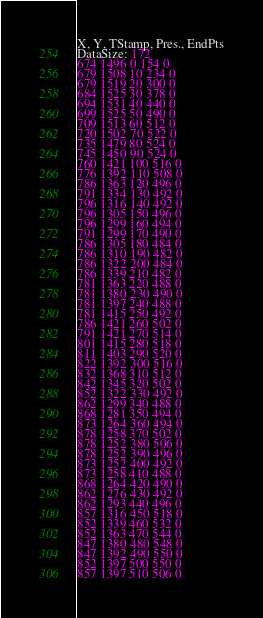<code> <loc_0><loc_0><loc_500><loc_500><_SML_>X, Y, TStamp, Pres., EndPts
DataSize: 172
674 1496 0 154 0
679 1508 10 234 0
679 1519 20 300 0
684 1525 30 378 0
694 1531 40 440 0
699 1525 50 490 0
709 1513 60 512 0
720 1502 70 522 0
735 1479 80 524 0
745 1450 90 524 0
760 1421 100 516 0
776 1392 110 508 0
786 1363 120 496 0
791 1334 130 492 0
796 1316 140 492 0
796 1305 150 496 0
796 1299 160 494 0
791 1299 170 490 0
786 1305 180 484 0
786 1310 190 482 0
786 1322 200 484 0
786 1339 210 482 0
781 1363 220 488 0
781 1380 230 490 0
781 1397 240 488 0
781 1415 250 492 0
786 1421 260 502 0
791 1421 270 514 0
801 1415 280 518 0
811 1403 290 520 0
822 1392 300 516 0
832 1368 310 512 0
842 1345 320 502 0
852 1322 330 492 0
862 1299 340 488 0
868 1281 350 494 0
873 1264 360 494 0
878 1258 370 502 0
878 1252 380 506 0
878 1252 390 496 0
873 1252 400 492 0
873 1258 410 488 0
868 1264 420 490 0
862 1276 430 492 0
862 1293 440 496 0
857 1316 450 518 0
852 1339 460 532 0
852 1363 470 544 0
847 1380 480 548 0
847 1392 490 550 0
852 1397 500 550 0
857 1397 510 506 0</code> 